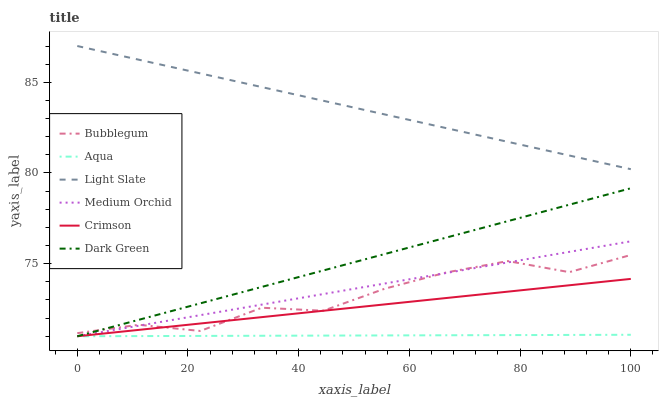Does Aqua have the minimum area under the curve?
Answer yes or no. Yes. Does Light Slate have the maximum area under the curve?
Answer yes or no. Yes. Does Medium Orchid have the minimum area under the curve?
Answer yes or no. No. Does Medium Orchid have the maximum area under the curve?
Answer yes or no. No. Is Medium Orchid the smoothest?
Answer yes or no. Yes. Is Bubblegum the roughest?
Answer yes or no. Yes. Is Aqua the smoothest?
Answer yes or no. No. Is Aqua the roughest?
Answer yes or no. No. Does Medium Orchid have the lowest value?
Answer yes or no. Yes. Does Bubblegum have the lowest value?
Answer yes or no. No. Does Light Slate have the highest value?
Answer yes or no. Yes. Does Medium Orchid have the highest value?
Answer yes or no. No. Is Crimson less than Light Slate?
Answer yes or no. Yes. Is Light Slate greater than Aqua?
Answer yes or no. Yes. Does Dark Green intersect Bubblegum?
Answer yes or no. Yes. Is Dark Green less than Bubblegum?
Answer yes or no. No. Is Dark Green greater than Bubblegum?
Answer yes or no. No. Does Crimson intersect Light Slate?
Answer yes or no. No. 